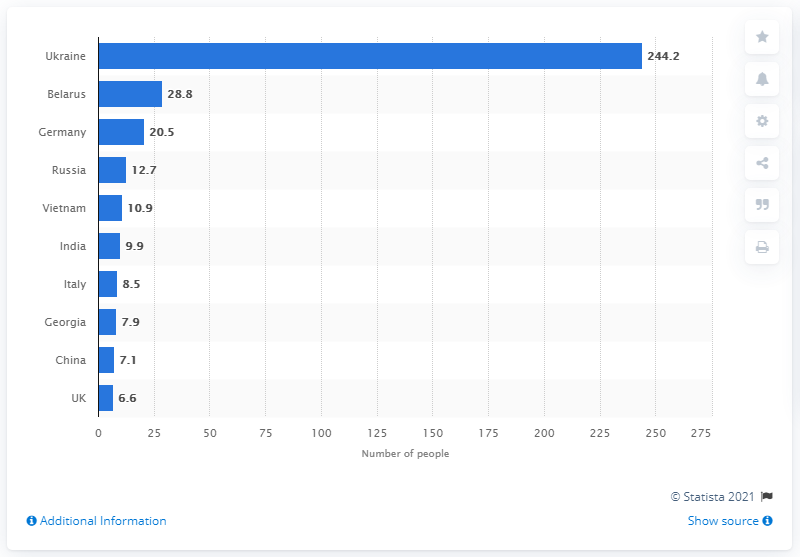Identify some key points in this picture. The majority of the people in Poland originated from Ukraine. 